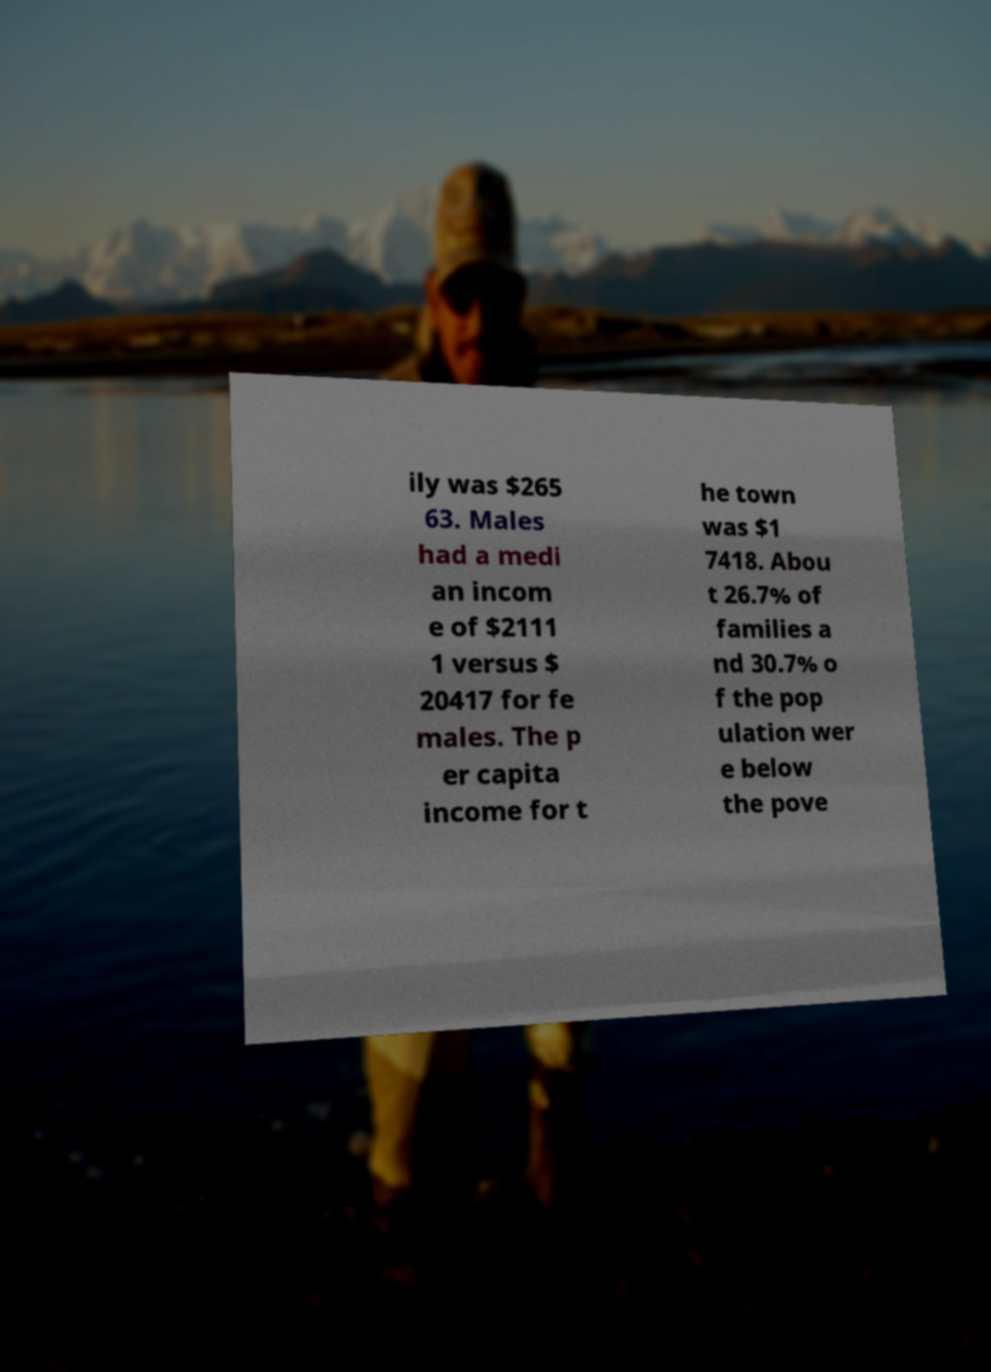Could you assist in decoding the text presented in this image and type it out clearly? ily was $265 63. Males had a medi an incom e of $2111 1 versus $ 20417 for fe males. The p er capita income for t he town was $1 7418. Abou t 26.7% of families a nd 30.7% o f the pop ulation wer e below the pove 